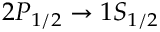Convert formula to latex. <formula><loc_0><loc_0><loc_500><loc_500>2 P _ { 1 / 2 } \to 1 S _ { 1 / 2 }</formula> 